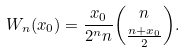Convert formula to latex. <formula><loc_0><loc_0><loc_500><loc_500>W _ { n } ( x _ { 0 } ) = \frac { x _ { 0 } } { 2 ^ { n } n } \binom { n } { \frac { n + x _ { 0 } } { 2 } } .</formula> 